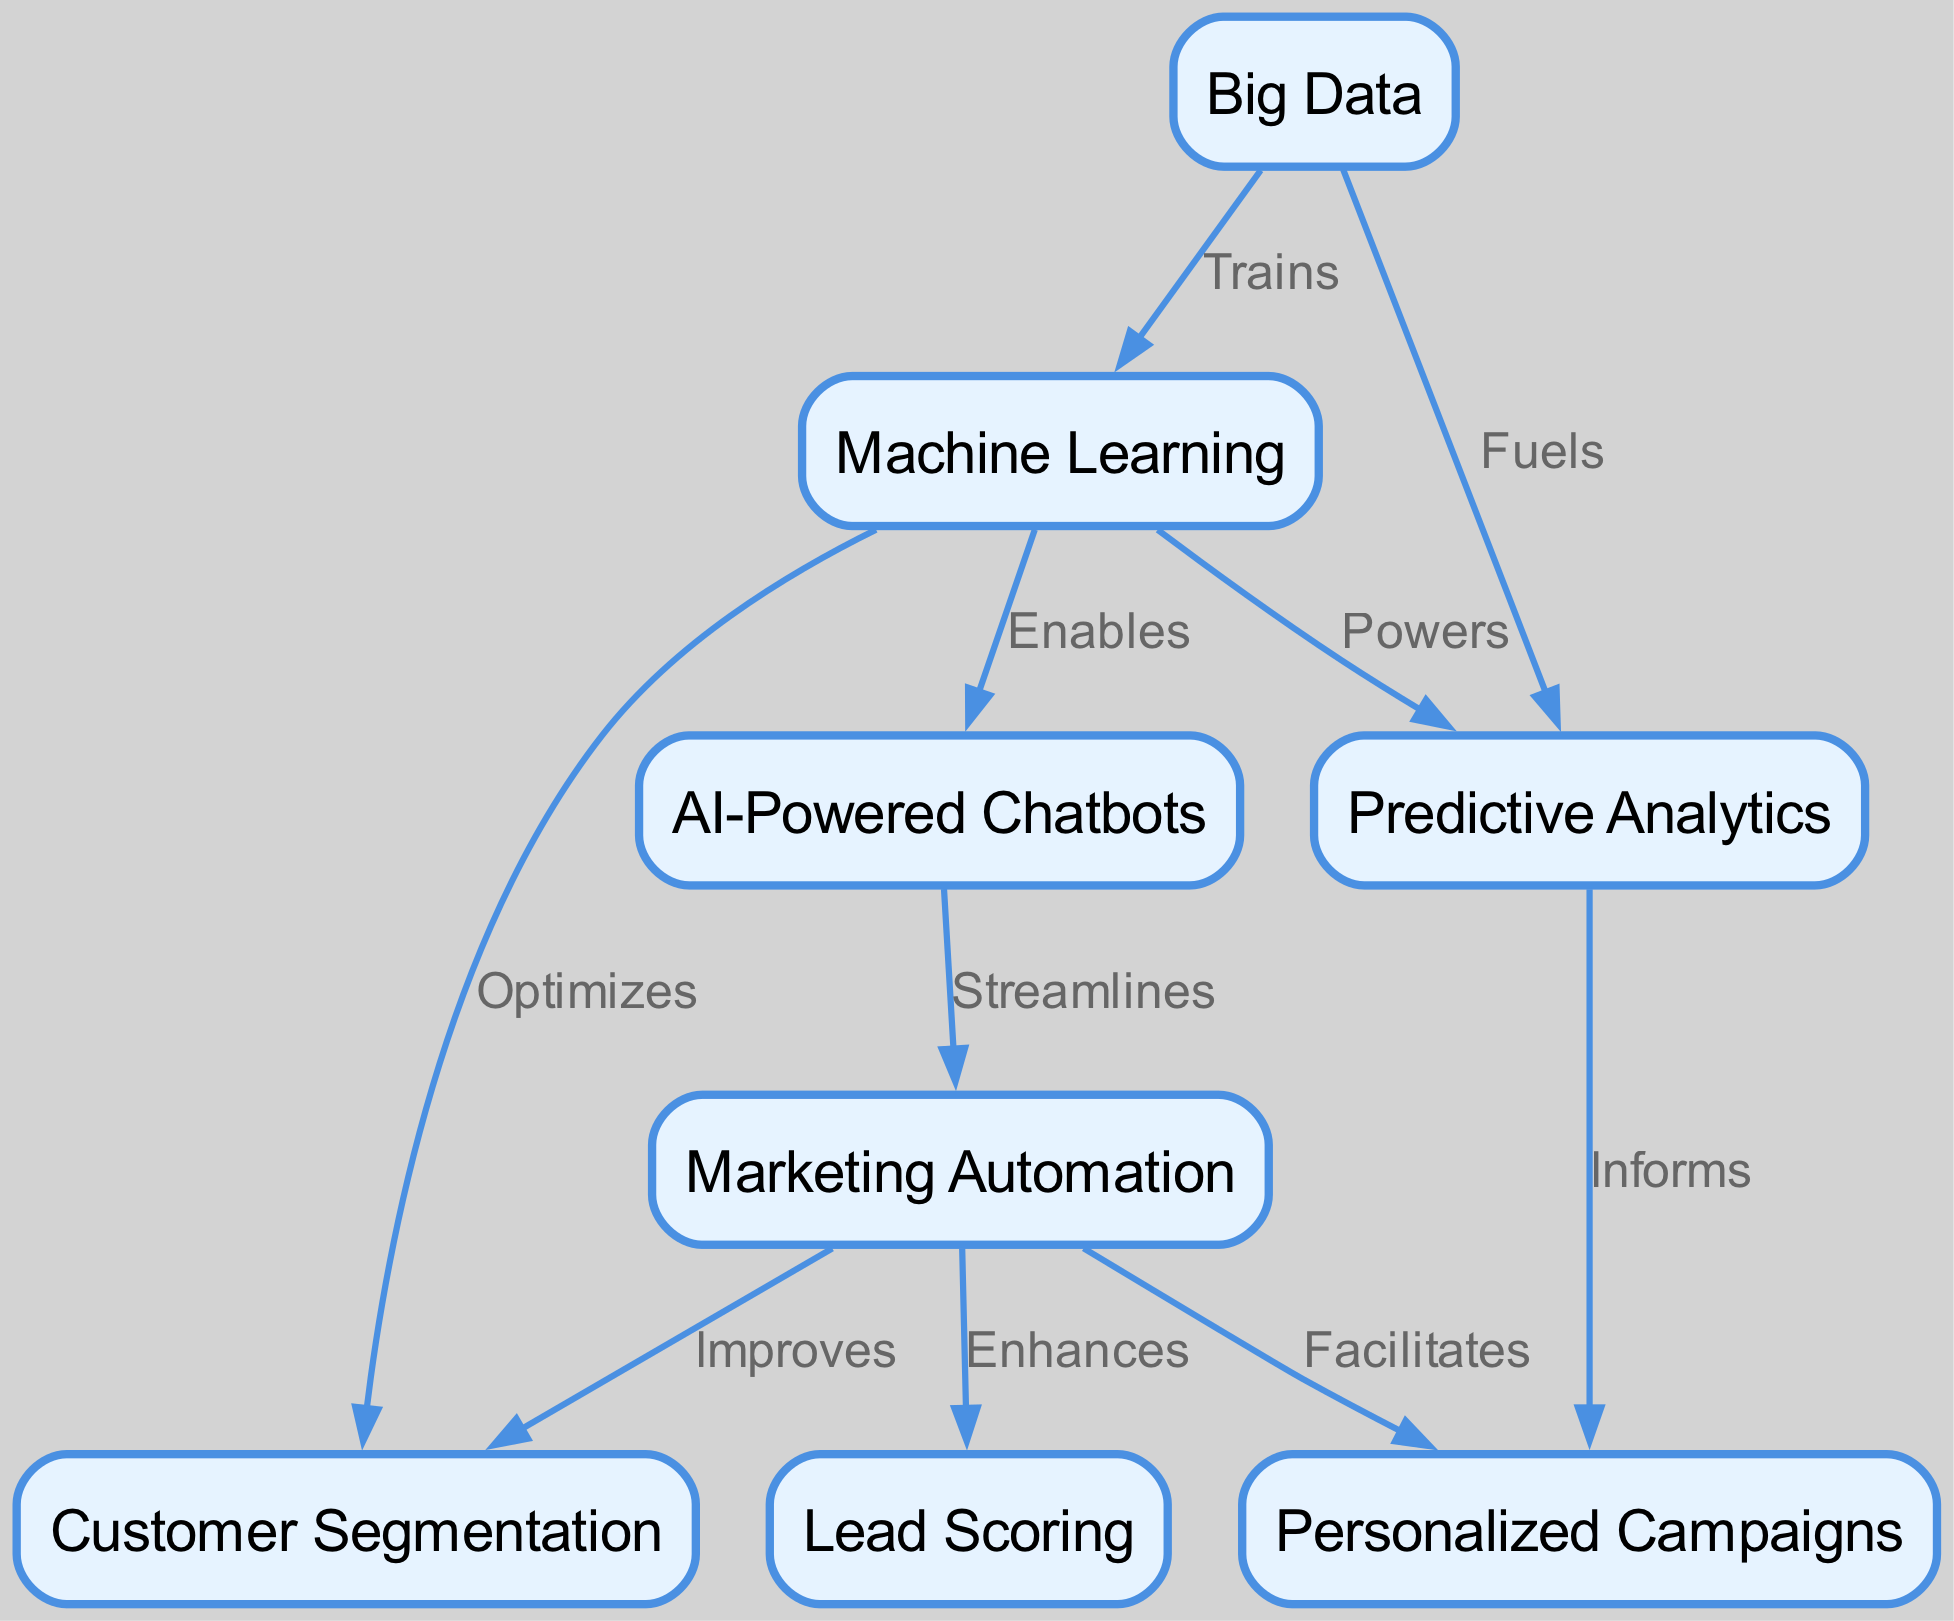What is one application of AI-Powered Chatbots in marketing automation? The diagram shows that AI-Powered Chatbots streamline Marketing Automation, indicating their role in making marketing processes more efficient and responsive.
Answer: Streamlines Which emerging technology optimizes Customer Segmentation? The diagram illustrates that Machine Learning optimizes Customer Segmentation, highlighting its use in enhancing the classification of customers based on behavior and preferences.
Answer: Machine Learning How many nodes are present in the diagram? Counting the nodes in the diagram reveals there are eight distinct nodes representing various concepts in marketing automation and emerging technologies.
Answer: Eight What relationship does Big Data have with Predictive Analytics? The diagram indicates that Big Data fuels Predictive Analytics, suggesting that the vast amounts of data available significantly enhance the ability to forecast future trends and behaviors.
Answer: Fuels Which technology enables AI-Powered Chatbots? According to the diagram, Machine Learning enables AI-Powered Chatbots by providing the algorithms and models that allow these chatbots to understand and respond to user inquiries effectively.
Answer: Machine Learning What are the two outcomes of using Marketing Automation, according to the diagram? The diagram shows three relationships for Marketing Automation: it facilitates Personalized Campaigns, improves Customer Segmentation, and enhances Lead Scoring, indicating multiple positive outcomes of its implementation.
Answer: Personalized Campaigns and Customer Segmentation What does Predictive Analytics inform in marketing automation? The diagram clearly states that Predictive Analytics informs Personalized Campaigns, indicating its role in developing targeted marketing strategies based on data insights.
Answer: Personalized Campaigns Which node has the most edges leading from it? By analyzing the connections, it is evident that Marketing Automation has three edges leading from it, demonstrating its central role in linking various elements of marketing strategy.
Answer: Marketing Automation What relationship connects Machine Learning to AI-Powered Chatbots? The diagram shows that Machine Learning enables AI-Powered Chatbots, indicating the foundational role of Machine Learning technologies in the development and functionality of such automated systems.
Answer: Enables 